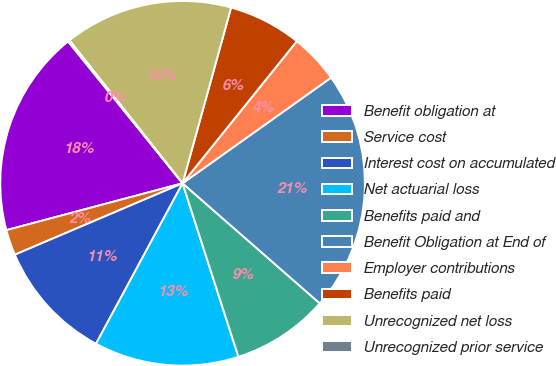Convert chart to OTSL. <chart><loc_0><loc_0><loc_500><loc_500><pie_chart><fcel>Benefit obligation at<fcel>Service cost<fcel>Interest cost on accumulated<fcel>Net actuarial loss<fcel>Benefits paid and<fcel>Benefit Obligation at End of<fcel>Employer contributions<fcel>Benefits paid<fcel>Unrecognized net loss<fcel>Unrecognized prior service<nl><fcel>18.33%<fcel>2.27%<fcel>10.72%<fcel>12.83%<fcel>8.6%<fcel>21.28%<fcel>4.38%<fcel>6.49%<fcel>14.94%<fcel>0.15%<nl></chart> 